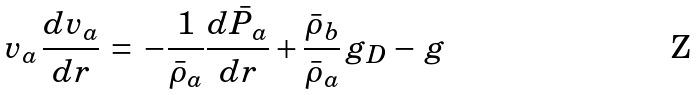<formula> <loc_0><loc_0><loc_500><loc_500>v _ { a } \, \frac { d v _ { a } } { d r } \, = \, - \frac { 1 } { \bar { \rho } _ { a } } \frac { d \bar { P } _ { a } } { d r } + \frac { \bar { \rho } _ { b } } { \bar { \rho } _ { a } } \, g _ { D } - \, g</formula> 